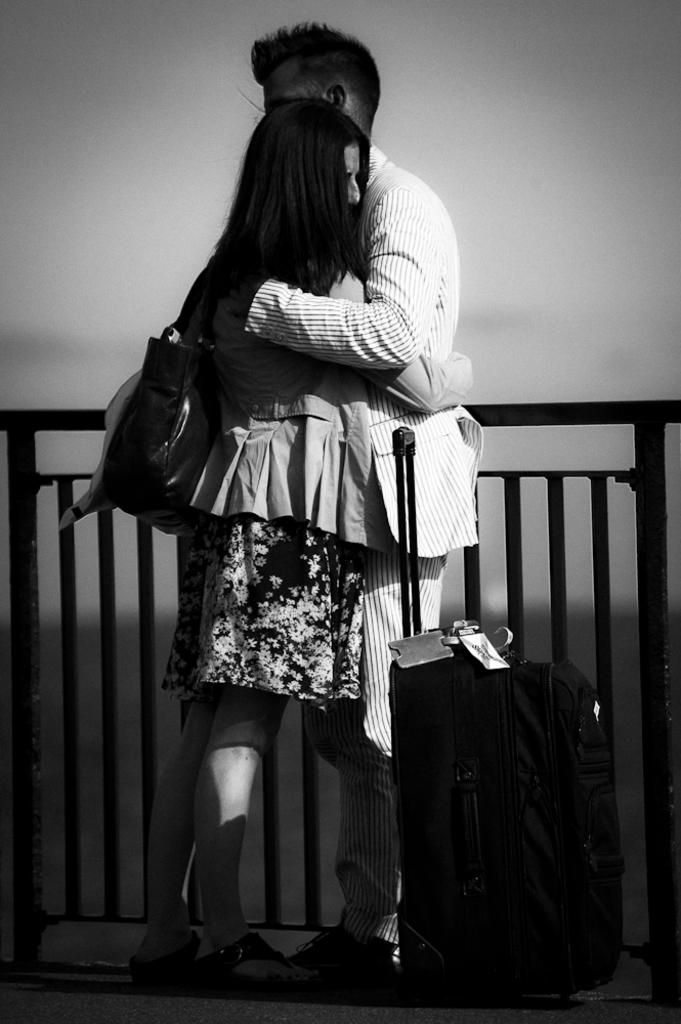What is the color scheme of the image? The image is black and white. Who are the people in the image? There is a man and a girl in the image. What are the man and the girl doing? The man and the girl are hugging. What objects are in front of them? There is luggage in front of them. What can be seen in the background of the image? There is a railing in the background of the image. What type of thrill ride can be seen in the background of the image? There is no thrill ride present in the image; it features a railing in the background. Can you tell me how many kittens are sitting on the luggage in the image? There are no kittens present in the image; it only shows luggage in front of the man and the girl. 